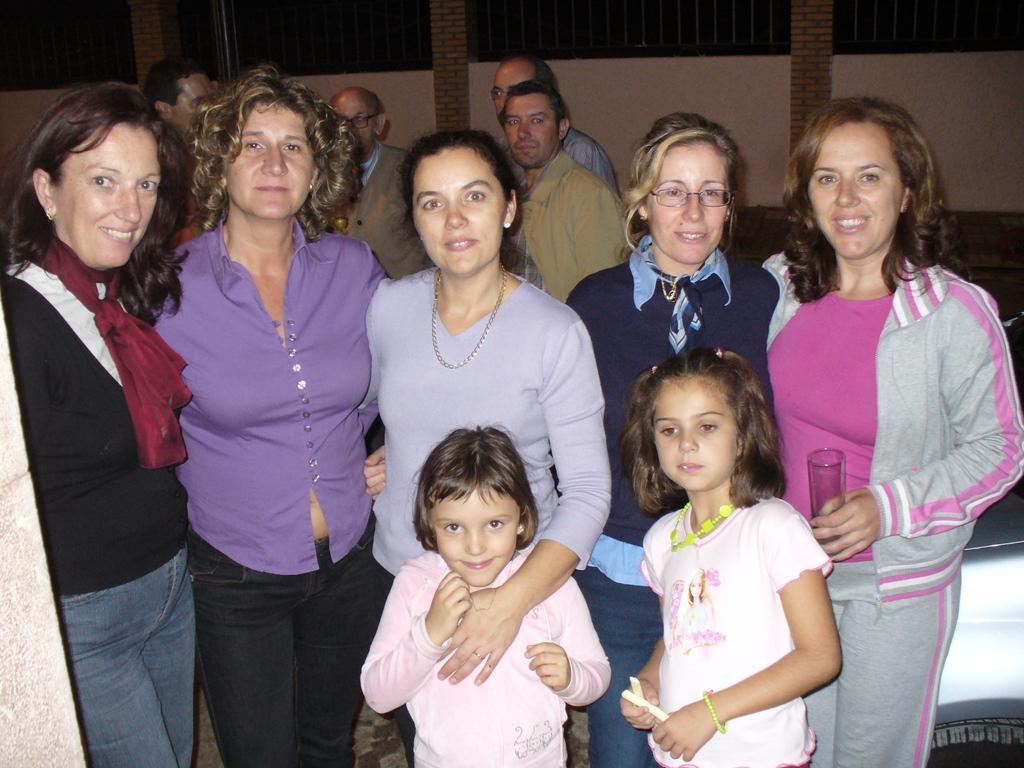Describe this image in one or two sentences. In front of the picture, we see five women and two girls are standing. All of them are smiling and they are posing for the photo. Behind them, we see four men are standing. On the right side, we see the car. In the background, we see a wall. This picture might be clicked in the dark. 